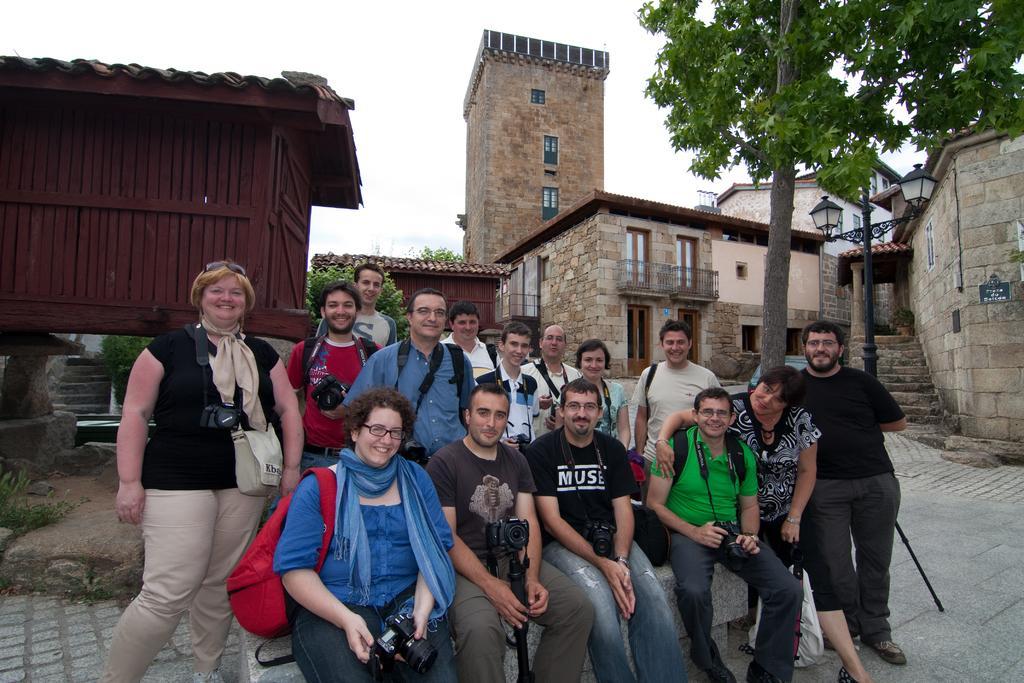Describe this image in one or two sentences. There are some people standing and sitting. Some are holding cameras, bags. Some are wearing scarves. In the back there are buildings with windows and balconies. Also there is a street light pole and a tree. There are steps for a building. In the background there is sky. 